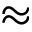<formula> <loc_0><loc_0><loc_500><loc_500>\approx</formula> 